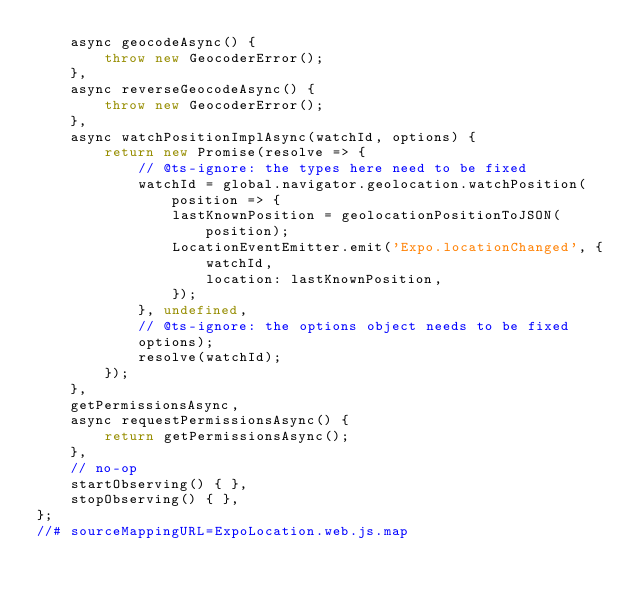Convert code to text. <code><loc_0><loc_0><loc_500><loc_500><_JavaScript_>    async geocodeAsync() {
        throw new GeocoderError();
    },
    async reverseGeocodeAsync() {
        throw new GeocoderError();
    },
    async watchPositionImplAsync(watchId, options) {
        return new Promise(resolve => {
            // @ts-ignore: the types here need to be fixed
            watchId = global.navigator.geolocation.watchPosition(position => {
                lastKnownPosition = geolocationPositionToJSON(position);
                LocationEventEmitter.emit('Expo.locationChanged', {
                    watchId,
                    location: lastKnownPosition,
                });
            }, undefined, 
            // @ts-ignore: the options object needs to be fixed
            options);
            resolve(watchId);
        });
    },
    getPermissionsAsync,
    async requestPermissionsAsync() {
        return getPermissionsAsync();
    },
    // no-op
    startObserving() { },
    stopObserving() { },
};
//# sourceMappingURL=ExpoLocation.web.js.map</code> 